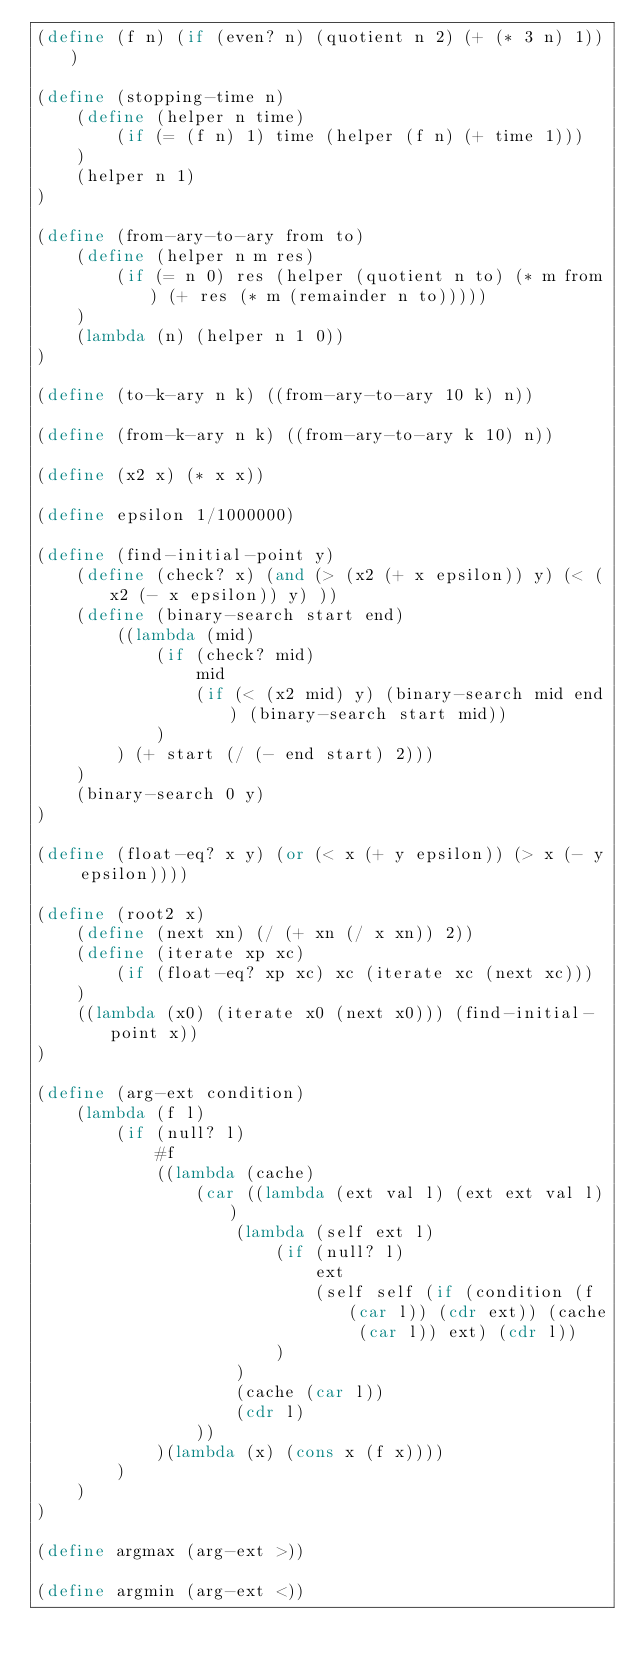<code> <loc_0><loc_0><loc_500><loc_500><_Scheme_>(define (f n) (if (even? n) (quotient n 2) (+ (* 3 n) 1)))

(define (stopping-time n)
    (define (helper n time)
        (if (= (f n) 1) time (helper (f n) (+ time 1)))
    )
    (helper n 1)
)

(define (from-ary-to-ary from to)
    (define (helper n m res)
        (if (= n 0) res (helper (quotient n to) (* m from) (+ res (* m (remainder n to))))) 
    )
    (lambda (n) (helper n 1 0))
)

(define (to-k-ary n k) ((from-ary-to-ary 10 k) n))

(define (from-k-ary n k) ((from-ary-to-ary k 10) n))

(define (x2 x) (* x x))

(define epsilon 1/1000000)

(define (find-initial-point y)
    (define (check? x) (and (> (x2 (+ x epsilon)) y) (< (x2 (- x epsilon)) y) ))
    (define (binary-search start end)
        ((lambda (mid)
            (if (check? mid)
                mid
                (if (< (x2 mid) y) (binary-search mid end) (binary-search start mid))   
            )
        ) (+ start (/ (- end start) 2)))
    )
    (binary-search 0 y)
)

(define (float-eq? x y) (or (< x (+ y epsilon)) (> x (- y epsilon))))

(define (root2 x)
    (define (next xn) (/ (+ xn (/ x xn)) 2))
    (define (iterate xp xc)
        (if (float-eq? xp xc) xc (iterate xc (next xc))) 
    )
    ((lambda (x0) (iterate x0 (next x0))) (find-initial-point x))
)

(define (arg-ext condition)
    (lambda (f l)
        (if (null? l)
            #f
            ((lambda (cache)
                (car ((lambda (ext val l) (ext ext val l))
                    (lambda (self ext l)
                        (if (null? l)
                            ext
                            (self self (if (condition (f (car l)) (cdr ext)) (cache (car l)) ext) (cdr l))
                        )
                    )
                    (cache (car l))
                    (cdr l)
                ))
            )(lambda (x) (cons x (f x))))
        )
    )
)

(define argmax (arg-ext >))

(define argmin (arg-ext <))</code> 